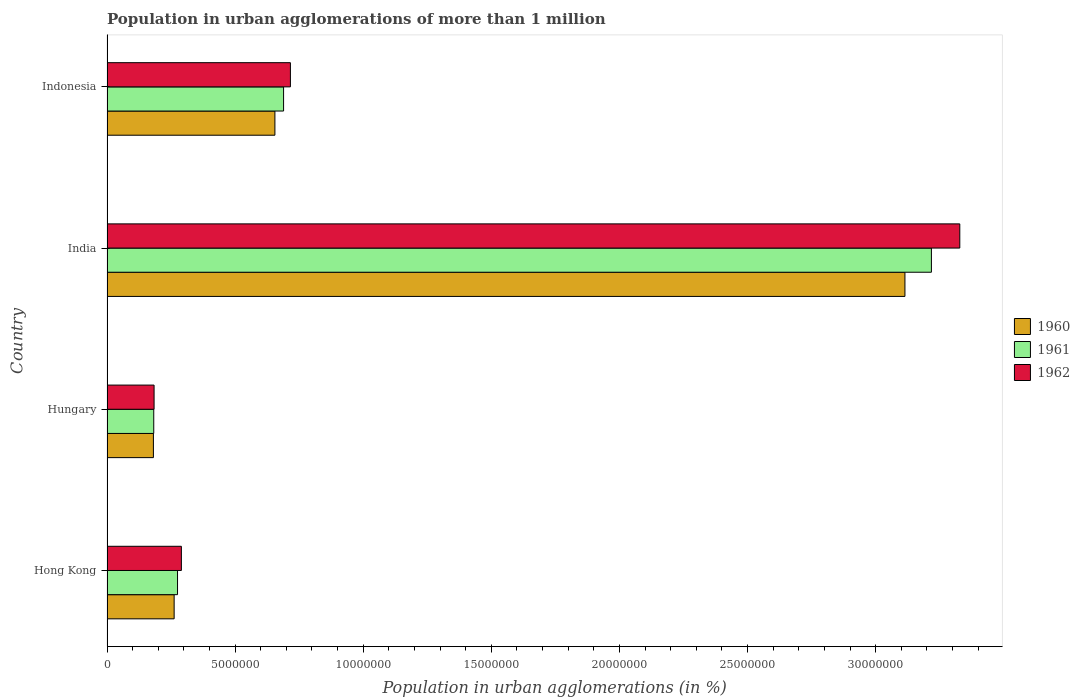Are the number of bars per tick equal to the number of legend labels?
Offer a very short reply. Yes. What is the label of the 4th group of bars from the top?
Provide a succinct answer. Hong Kong. In how many cases, is the number of bars for a given country not equal to the number of legend labels?
Your response must be concise. 0. What is the population in urban agglomerations in 1960 in Hong Kong?
Offer a terse response. 2.62e+06. Across all countries, what is the maximum population in urban agglomerations in 1962?
Offer a terse response. 3.33e+07. Across all countries, what is the minimum population in urban agglomerations in 1960?
Give a very brief answer. 1.81e+06. In which country was the population in urban agglomerations in 1961 maximum?
Offer a very short reply. India. In which country was the population in urban agglomerations in 1961 minimum?
Make the answer very short. Hungary. What is the total population in urban agglomerations in 1960 in the graph?
Provide a succinct answer. 4.21e+07. What is the difference between the population in urban agglomerations in 1961 in India and that in Indonesia?
Give a very brief answer. 2.53e+07. What is the difference between the population in urban agglomerations in 1961 in Hungary and the population in urban agglomerations in 1960 in Indonesia?
Your answer should be compact. -4.73e+06. What is the average population in urban agglomerations in 1961 per country?
Your answer should be very brief. 1.09e+07. What is the difference between the population in urban agglomerations in 1962 and population in urban agglomerations in 1961 in Hungary?
Keep it short and to the point. 1.33e+04. In how many countries, is the population in urban agglomerations in 1962 greater than 14000000 %?
Offer a very short reply. 1. What is the ratio of the population in urban agglomerations in 1961 in Hong Kong to that in India?
Make the answer very short. 0.09. What is the difference between the highest and the second highest population in urban agglomerations in 1961?
Offer a very short reply. 2.53e+07. What is the difference between the highest and the lowest population in urban agglomerations in 1962?
Your answer should be compact. 3.14e+07. In how many countries, is the population in urban agglomerations in 1961 greater than the average population in urban agglomerations in 1961 taken over all countries?
Your answer should be compact. 1. What does the 2nd bar from the top in India represents?
Provide a short and direct response. 1961. Are all the bars in the graph horizontal?
Your response must be concise. Yes. Does the graph contain grids?
Your answer should be very brief. No. How many legend labels are there?
Offer a terse response. 3. What is the title of the graph?
Ensure brevity in your answer.  Population in urban agglomerations of more than 1 million. What is the label or title of the X-axis?
Offer a very short reply. Population in urban agglomerations (in %). What is the Population in urban agglomerations (in %) in 1960 in Hong Kong?
Provide a short and direct response. 2.62e+06. What is the Population in urban agglomerations (in %) of 1961 in Hong Kong?
Offer a terse response. 2.75e+06. What is the Population in urban agglomerations (in %) of 1962 in Hong Kong?
Give a very brief answer. 2.90e+06. What is the Population in urban agglomerations (in %) of 1960 in Hungary?
Offer a very short reply. 1.81e+06. What is the Population in urban agglomerations (in %) in 1961 in Hungary?
Make the answer very short. 1.82e+06. What is the Population in urban agglomerations (in %) of 1962 in Hungary?
Your answer should be very brief. 1.84e+06. What is the Population in urban agglomerations (in %) in 1960 in India?
Your answer should be compact. 3.11e+07. What is the Population in urban agglomerations (in %) in 1961 in India?
Offer a terse response. 3.22e+07. What is the Population in urban agglomerations (in %) of 1962 in India?
Your response must be concise. 3.33e+07. What is the Population in urban agglomerations (in %) of 1960 in Indonesia?
Offer a very short reply. 6.55e+06. What is the Population in urban agglomerations (in %) of 1961 in Indonesia?
Provide a short and direct response. 6.89e+06. What is the Population in urban agglomerations (in %) in 1962 in Indonesia?
Offer a terse response. 7.16e+06. Across all countries, what is the maximum Population in urban agglomerations (in %) in 1960?
Your answer should be very brief. 3.11e+07. Across all countries, what is the maximum Population in urban agglomerations (in %) in 1961?
Provide a succinct answer. 3.22e+07. Across all countries, what is the maximum Population in urban agglomerations (in %) of 1962?
Give a very brief answer. 3.33e+07. Across all countries, what is the minimum Population in urban agglomerations (in %) in 1960?
Your answer should be very brief. 1.81e+06. Across all countries, what is the minimum Population in urban agglomerations (in %) in 1961?
Provide a short and direct response. 1.82e+06. Across all countries, what is the minimum Population in urban agglomerations (in %) in 1962?
Make the answer very short. 1.84e+06. What is the total Population in urban agglomerations (in %) of 1960 in the graph?
Your response must be concise. 4.21e+07. What is the total Population in urban agglomerations (in %) of 1961 in the graph?
Your answer should be compact. 4.36e+07. What is the total Population in urban agglomerations (in %) of 1962 in the graph?
Your answer should be very brief. 4.52e+07. What is the difference between the Population in urban agglomerations (in %) of 1960 in Hong Kong and that in Hungary?
Keep it short and to the point. 8.09e+05. What is the difference between the Population in urban agglomerations (in %) of 1961 in Hong Kong and that in Hungary?
Keep it short and to the point. 9.28e+05. What is the difference between the Population in urban agglomerations (in %) of 1962 in Hong Kong and that in Hungary?
Ensure brevity in your answer.  1.07e+06. What is the difference between the Population in urban agglomerations (in %) in 1960 in Hong Kong and that in India?
Provide a short and direct response. -2.85e+07. What is the difference between the Population in urban agglomerations (in %) in 1961 in Hong Kong and that in India?
Ensure brevity in your answer.  -2.94e+07. What is the difference between the Population in urban agglomerations (in %) in 1962 in Hong Kong and that in India?
Provide a short and direct response. -3.04e+07. What is the difference between the Population in urban agglomerations (in %) of 1960 in Hong Kong and that in Indonesia?
Make the answer very short. -3.93e+06. What is the difference between the Population in urban agglomerations (in %) in 1961 in Hong Kong and that in Indonesia?
Offer a very short reply. -4.14e+06. What is the difference between the Population in urban agglomerations (in %) of 1962 in Hong Kong and that in Indonesia?
Keep it short and to the point. -4.26e+06. What is the difference between the Population in urban agglomerations (in %) of 1960 in Hungary and that in India?
Offer a very short reply. -2.93e+07. What is the difference between the Population in urban agglomerations (in %) of 1961 in Hungary and that in India?
Give a very brief answer. -3.04e+07. What is the difference between the Population in urban agglomerations (in %) in 1962 in Hungary and that in India?
Keep it short and to the point. -3.14e+07. What is the difference between the Population in urban agglomerations (in %) in 1960 in Hungary and that in Indonesia?
Your answer should be compact. -4.74e+06. What is the difference between the Population in urban agglomerations (in %) of 1961 in Hungary and that in Indonesia?
Offer a very short reply. -5.07e+06. What is the difference between the Population in urban agglomerations (in %) of 1962 in Hungary and that in Indonesia?
Your answer should be very brief. -5.32e+06. What is the difference between the Population in urban agglomerations (in %) in 1960 in India and that in Indonesia?
Keep it short and to the point. 2.46e+07. What is the difference between the Population in urban agglomerations (in %) in 1961 in India and that in Indonesia?
Your answer should be compact. 2.53e+07. What is the difference between the Population in urban agglomerations (in %) of 1962 in India and that in Indonesia?
Offer a very short reply. 2.61e+07. What is the difference between the Population in urban agglomerations (in %) of 1960 in Hong Kong and the Population in urban agglomerations (in %) of 1961 in Hungary?
Your answer should be compact. 7.96e+05. What is the difference between the Population in urban agglomerations (in %) in 1960 in Hong Kong and the Population in urban agglomerations (in %) in 1962 in Hungary?
Offer a terse response. 7.83e+05. What is the difference between the Population in urban agglomerations (in %) in 1961 in Hong Kong and the Population in urban agglomerations (in %) in 1962 in Hungary?
Keep it short and to the point. 9.15e+05. What is the difference between the Population in urban agglomerations (in %) in 1960 in Hong Kong and the Population in urban agglomerations (in %) in 1961 in India?
Your response must be concise. -2.96e+07. What is the difference between the Population in urban agglomerations (in %) of 1960 in Hong Kong and the Population in urban agglomerations (in %) of 1962 in India?
Your response must be concise. -3.07e+07. What is the difference between the Population in urban agglomerations (in %) of 1961 in Hong Kong and the Population in urban agglomerations (in %) of 1962 in India?
Ensure brevity in your answer.  -3.05e+07. What is the difference between the Population in urban agglomerations (in %) of 1960 in Hong Kong and the Population in urban agglomerations (in %) of 1961 in Indonesia?
Ensure brevity in your answer.  -4.27e+06. What is the difference between the Population in urban agglomerations (in %) of 1960 in Hong Kong and the Population in urban agglomerations (in %) of 1962 in Indonesia?
Keep it short and to the point. -4.54e+06. What is the difference between the Population in urban agglomerations (in %) in 1961 in Hong Kong and the Population in urban agglomerations (in %) in 1962 in Indonesia?
Ensure brevity in your answer.  -4.41e+06. What is the difference between the Population in urban agglomerations (in %) in 1960 in Hungary and the Population in urban agglomerations (in %) in 1961 in India?
Make the answer very short. -3.04e+07. What is the difference between the Population in urban agglomerations (in %) in 1960 in Hungary and the Population in urban agglomerations (in %) in 1962 in India?
Give a very brief answer. -3.15e+07. What is the difference between the Population in urban agglomerations (in %) in 1961 in Hungary and the Population in urban agglomerations (in %) in 1962 in India?
Your answer should be compact. -3.15e+07. What is the difference between the Population in urban agglomerations (in %) in 1960 in Hungary and the Population in urban agglomerations (in %) in 1961 in Indonesia?
Your answer should be compact. -5.08e+06. What is the difference between the Population in urban agglomerations (in %) of 1960 in Hungary and the Population in urban agglomerations (in %) of 1962 in Indonesia?
Make the answer very short. -5.35e+06. What is the difference between the Population in urban agglomerations (in %) in 1961 in Hungary and the Population in urban agglomerations (in %) in 1962 in Indonesia?
Your answer should be very brief. -5.33e+06. What is the difference between the Population in urban agglomerations (in %) of 1960 in India and the Population in urban agglomerations (in %) of 1961 in Indonesia?
Your response must be concise. 2.43e+07. What is the difference between the Population in urban agglomerations (in %) in 1960 in India and the Population in urban agglomerations (in %) in 1962 in Indonesia?
Give a very brief answer. 2.40e+07. What is the difference between the Population in urban agglomerations (in %) of 1961 in India and the Population in urban agglomerations (in %) of 1962 in Indonesia?
Offer a terse response. 2.50e+07. What is the average Population in urban agglomerations (in %) in 1960 per country?
Offer a terse response. 1.05e+07. What is the average Population in urban agglomerations (in %) in 1961 per country?
Make the answer very short. 1.09e+07. What is the average Population in urban agglomerations (in %) in 1962 per country?
Your answer should be very brief. 1.13e+07. What is the difference between the Population in urban agglomerations (in %) in 1960 and Population in urban agglomerations (in %) in 1961 in Hong Kong?
Offer a very short reply. -1.32e+05. What is the difference between the Population in urban agglomerations (in %) in 1960 and Population in urban agglomerations (in %) in 1962 in Hong Kong?
Your response must be concise. -2.82e+05. What is the difference between the Population in urban agglomerations (in %) of 1961 and Population in urban agglomerations (in %) of 1962 in Hong Kong?
Your answer should be very brief. -1.50e+05. What is the difference between the Population in urban agglomerations (in %) of 1960 and Population in urban agglomerations (in %) of 1961 in Hungary?
Provide a succinct answer. -1.32e+04. What is the difference between the Population in urban agglomerations (in %) of 1960 and Population in urban agglomerations (in %) of 1962 in Hungary?
Give a very brief answer. -2.64e+04. What is the difference between the Population in urban agglomerations (in %) in 1961 and Population in urban agglomerations (in %) in 1962 in Hungary?
Offer a terse response. -1.33e+04. What is the difference between the Population in urban agglomerations (in %) of 1960 and Population in urban agglomerations (in %) of 1961 in India?
Offer a terse response. -1.03e+06. What is the difference between the Population in urban agglomerations (in %) of 1960 and Population in urban agglomerations (in %) of 1962 in India?
Give a very brief answer. -2.14e+06. What is the difference between the Population in urban agglomerations (in %) of 1961 and Population in urban agglomerations (in %) of 1962 in India?
Keep it short and to the point. -1.11e+06. What is the difference between the Population in urban agglomerations (in %) in 1960 and Population in urban agglomerations (in %) in 1961 in Indonesia?
Provide a short and direct response. -3.38e+05. What is the difference between the Population in urban agglomerations (in %) of 1960 and Population in urban agglomerations (in %) of 1962 in Indonesia?
Make the answer very short. -6.05e+05. What is the difference between the Population in urban agglomerations (in %) in 1961 and Population in urban agglomerations (in %) in 1962 in Indonesia?
Keep it short and to the point. -2.67e+05. What is the ratio of the Population in urban agglomerations (in %) of 1960 in Hong Kong to that in Hungary?
Offer a very short reply. 1.45. What is the ratio of the Population in urban agglomerations (in %) of 1961 in Hong Kong to that in Hungary?
Make the answer very short. 1.51. What is the ratio of the Population in urban agglomerations (in %) of 1962 in Hong Kong to that in Hungary?
Make the answer very short. 1.58. What is the ratio of the Population in urban agglomerations (in %) in 1960 in Hong Kong to that in India?
Offer a terse response. 0.08. What is the ratio of the Population in urban agglomerations (in %) of 1961 in Hong Kong to that in India?
Your answer should be very brief. 0.09. What is the ratio of the Population in urban agglomerations (in %) in 1962 in Hong Kong to that in India?
Make the answer very short. 0.09. What is the ratio of the Population in urban agglomerations (in %) of 1960 in Hong Kong to that in Indonesia?
Ensure brevity in your answer.  0.4. What is the ratio of the Population in urban agglomerations (in %) of 1961 in Hong Kong to that in Indonesia?
Offer a very short reply. 0.4. What is the ratio of the Population in urban agglomerations (in %) in 1962 in Hong Kong to that in Indonesia?
Ensure brevity in your answer.  0.41. What is the ratio of the Population in urban agglomerations (in %) in 1960 in Hungary to that in India?
Your answer should be compact. 0.06. What is the ratio of the Population in urban agglomerations (in %) of 1961 in Hungary to that in India?
Keep it short and to the point. 0.06. What is the ratio of the Population in urban agglomerations (in %) of 1962 in Hungary to that in India?
Provide a succinct answer. 0.06. What is the ratio of the Population in urban agglomerations (in %) of 1960 in Hungary to that in Indonesia?
Your answer should be compact. 0.28. What is the ratio of the Population in urban agglomerations (in %) of 1961 in Hungary to that in Indonesia?
Ensure brevity in your answer.  0.26. What is the ratio of the Population in urban agglomerations (in %) in 1962 in Hungary to that in Indonesia?
Your answer should be compact. 0.26. What is the ratio of the Population in urban agglomerations (in %) in 1960 in India to that in Indonesia?
Provide a succinct answer. 4.75. What is the ratio of the Population in urban agglomerations (in %) in 1961 in India to that in Indonesia?
Offer a very short reply. 4.67. What is the ratio of the Population in urban agglomerations (in %) in 1962 in India to that in Indonesia?
Offer a very short reply. 4.65. What is the difference between the highest and the second highest Population in urban agglomerations (in %) of 1960?
Ensure brevity in your answer.  2.46e+07. What is the difference between the highest and the second highest Population in urban agglomerations (in %) of 1961?
Ensure brevity in your answer.  2.53e+07. What is the difference between the highest and the second highest Population in urban agglomerations (in %) of 1962?
Offer a terse response. 2.61e+07. What is the difference between the highest and the lowest Population in urban agglomerations (in %) of 1960?
Offer a terse response. 2.93e+07. What is the difference between the highest and the lowest Population in urban agglomerations (in %) of 1961?
Your response must be concise. 3.04e+07. What is the difference between the highest and the lowest Population in urban agglomerations (in %) of 1962?
Keep it short and to the point. 3.14e+07. 